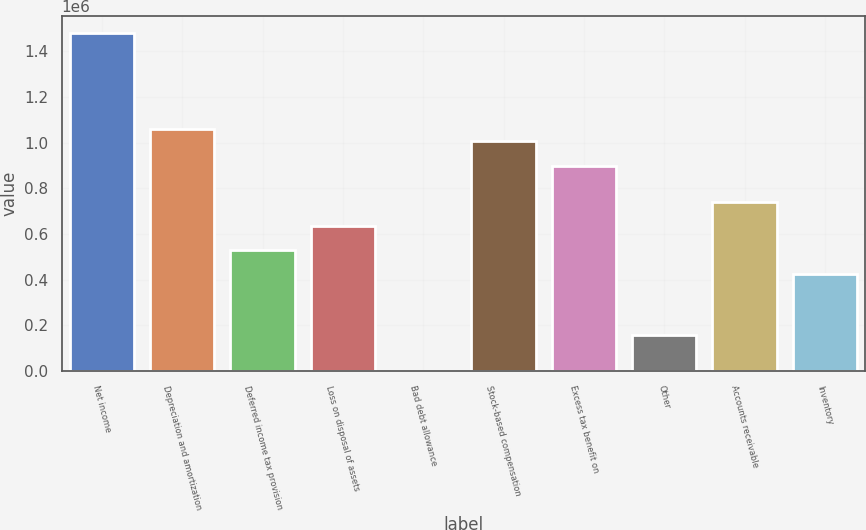Convert chart. <chart><loc_0><loc_0><loc_500><loc_500><bar_chart><fcel>Net income<fcel>Depreciation and amortization<fcel>Deferred income tax provision<fcel>Loss on disposal of assets<fcel>Bad debt allowance<fcel>Stock-based compensation<fcel>Excess tax benefit on<fcel>Other<fcel>Accounts receivable<fcel>Inventory<nl><fcel>1.48055e+06<fcel>1.05754e+06<fcel>528780<fcel>634532<fcel>19<fcel>1.00466e+06<fcel>898913<fcel>158647<fcel>740284<fcel>423028<nl></chart> 